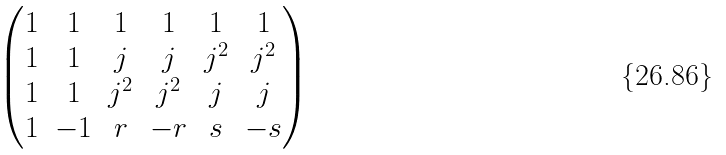<formula> <loc_0><loc_0><loc_500><loc_500>\begin{pmatrix} 1 & 1 & 1 & 1 & 1 & 1 \\ 1 & 1 & j & j & j ^ { 2 } & j ^ { 2 } \\ 1 & 1 & j ^ { 2 } & j ^ { 2 } & j & j \\ 1 & - 1 & r & - r & s & - s \end{pmatrix}</formula> 